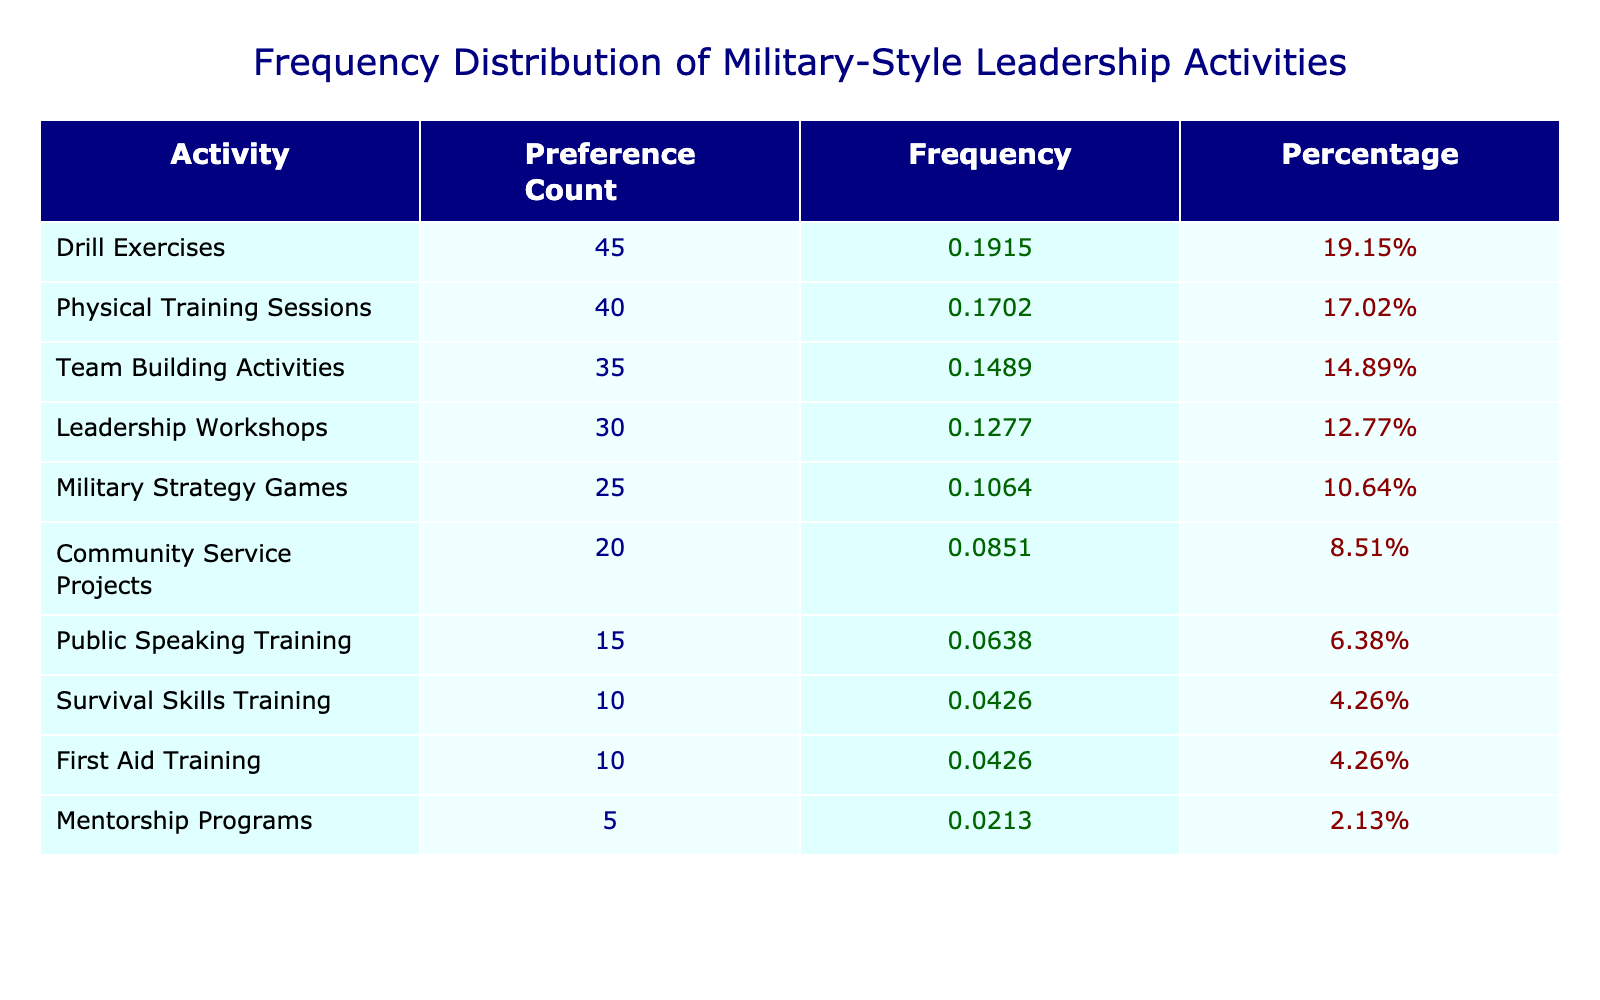What is the highest preference count for a military-style leadership activity? The highest preference count from the table is the first value in the "Preference Count" column, which is 45 for Drill Exercises.
Answer: 45 Which two activities have the closest preference counts? The closest values in the "Preference Count" column are Team Building Activities (35) and Physical Training Sessions (40). The difference is 5.
Answer: 35 and 40 What percentage of peers preferred Public Speaking Training? Public Speaking Training has a preference count of 15. The total preference count is 300, so the percentage is (15 / 300) * 100 = 5%.
Answer: 5% Is the preference for Survival Skills Training higher than for First Aid Training? Both activities have preference counts of 10. Therefore, the statement is false as they are equal.
Answer: No What is the total preference count of Drill Exercises and Physical Training Sessions combined? The combined preference count is Drill Exercises (45) plus Physical Training Sessions (40), totaling 45 + 40 = 85.
Answer: 85 Which activity has the lowest preference count, and what is that count? The lowest preference count in the table is Mentorship Programs, which has a count of 5.
Answer: 5 What is the average preference count for all activities listed? To find the average, we sum up the preference counts (300) and divide by the number of activities (10), resulting in an average of 30.
Answer: 30 Which activities have a preference count greater than 30? The activities with counts greater than 30 are Drill Exercises (45), Physical Training Sessions (40), and Team Building Activities (35), totaling 3 activities.
Answer: 3 If the top three activities are combined, what percentage of the total do they represent? The top three activities are Drill Exercises (45), Physical Training Sessions (40), and Team Building Activities (35). Their combined count is 45 + 40 + 35 = 120, making up (120 / 300) * 100 = 40% of the total preference count.
Answer: 40% 